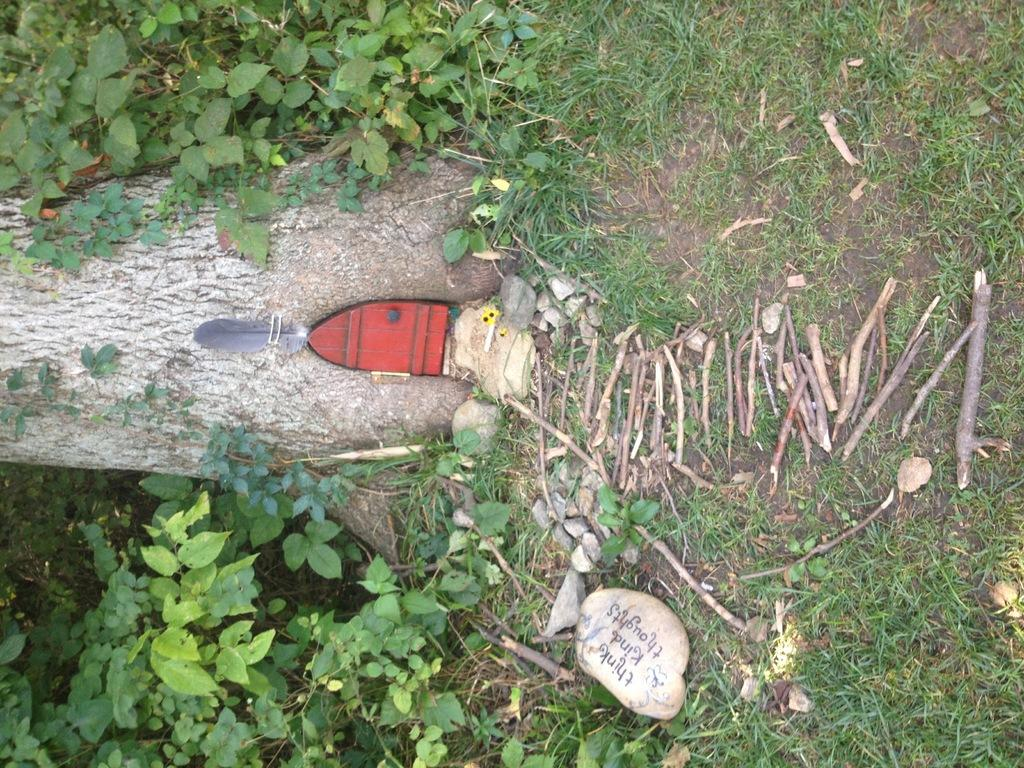What type of vegetation is on the right side of the image? There is grass on the right side of the image. What other natural elements can be seen on the right side of the image? There are twigs and stones visible on the right side of the image. What is located on the left side of the image? There are plants and the trunk of a tree visible on the left side of the image. What additional object can be seen on the left side of the image? There is a feather on the left side of the image. Are there any other objects present on the left side of the image? Yes, there are other objects on the left side of the image. How does the beginner learn to stretch and breathe in the image? There is no reference to a beginner or any learning activity in the image; it primarily features natural elements and objects. 